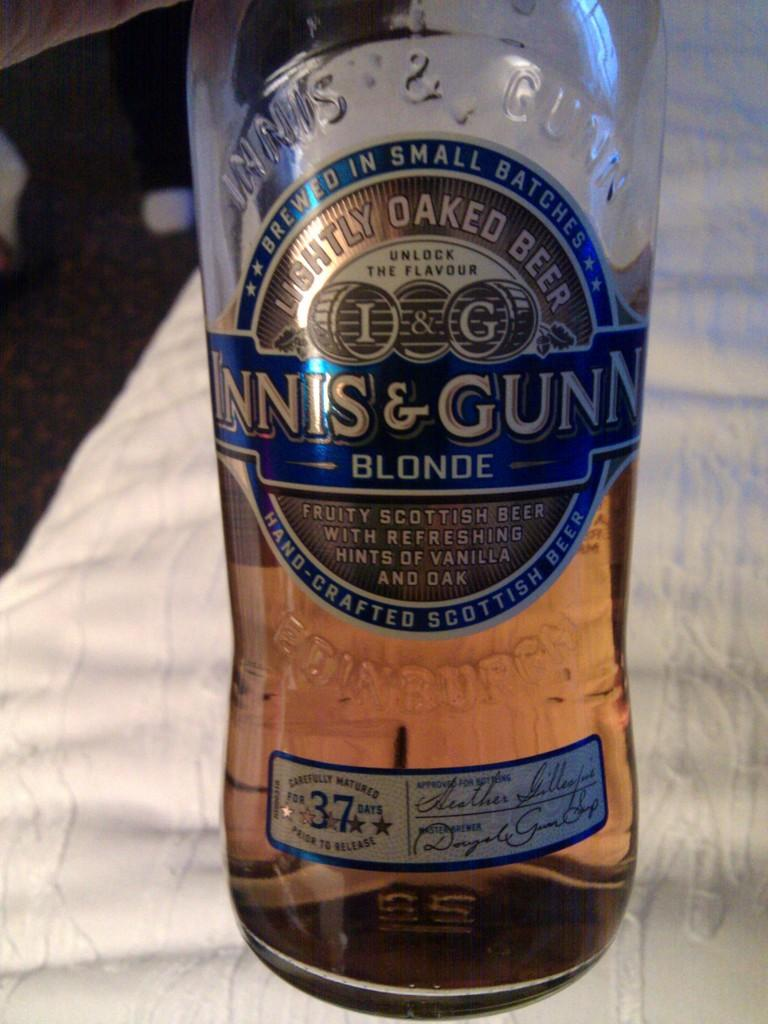What object is present in the image? There is a bottle in the image. What is on the bottle? The bottle has a sticker on it. What color is the background of the image? The background of the image is white. What type of channel is visible in the image? There is no channel present in the image; it only features a bottle with a sticker on it against a white background. 